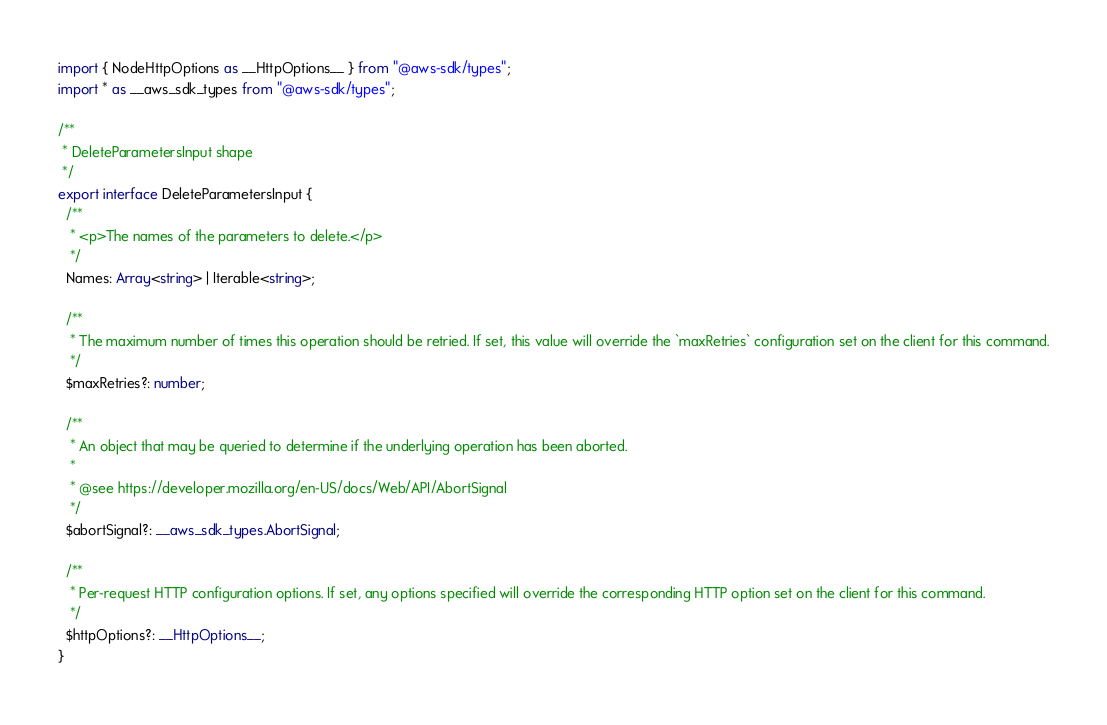Convert code to text. <code><loc_0><loc_0><loc_500><loc_500><_TypeScript_>import { NodeHttpOptions as __HttpOptions__ } from "@aws-sdk/types";
import * as __aws_sdk_types from "@aws-sdk/types";

/**
 * DeleteParametersInput shape
 */
export interface DeleteParametersInput {
  /**
   * <p>The names of the parameters to delete.</p>
   */
  Names: Array<string> | Iterable<string>;

  /**
   * The maximum number of times this operation should be retried. If set, this value will override the `maxRetries` configuration set on the client for this command.
   */
  $maxRetries?: number;

  /**
   * An object that may be queried to determine if the underlying operation has been aborted.
   *
   * @see https://developer.mozilla.org/en-US/docs/Web/API/AbortSignal
   */
  $abortSignal?: __aws_sdk_types.AbortSignal;

  /**
   * Per-request HTTP configuration options. If set, any options specified will override the corresponding HTTP option set on the client for this command.
   */
  $httpOptions?: __HttpOptions__;
}
</code> 